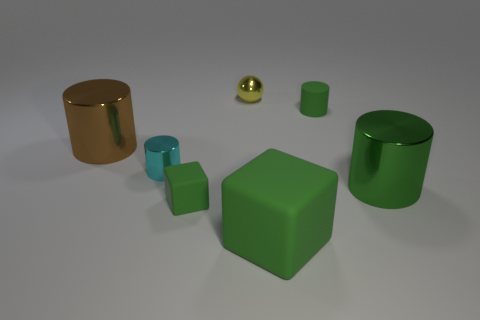Add 2 tiny yellow things. How many objects exist? 9 Subtract all cubes. How many objects are left? 5 Add 4 small green matte objects. How many small green matte objects are left? 6 Add 5 small red matte cylinders. How many small red matte cylinders exist? 5 Subtract 2 green cylinders. How many objects are left? 5 Subtract all large brown metallic cylinders. Subtract all tiny shiny balls. How many objects are left? 5 